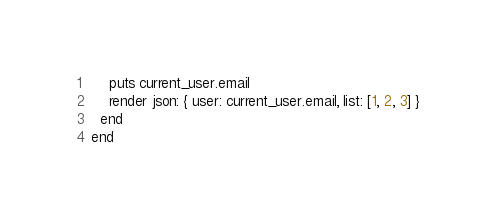Convert code to text. <code><loc_0><loc_0><loc_500><loc_500><_Ruby_>    puts current_user.email
    render json: { user: current_user.email, list: [1, 2, 3] }
  end
end</code> 